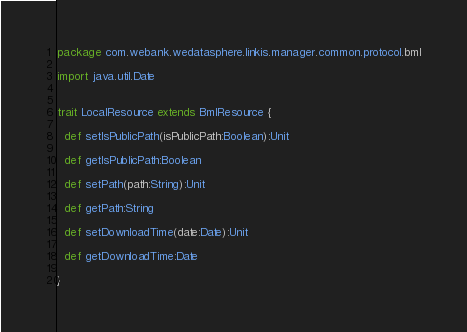Convert code to text. <code><loc_0><loc_0><loc_500><loc_500><_Scala_>package com.webank.wedatasphere.linkis.manager.common.protocol.bml

import java.util.Date


trait LocalResource extends BmlResource {

  def setIsPublicPath(isPublicPath:Boolean):Unit

  def getIsPublicPath:Boolean

  def setPath(path:String):Unit

  def getPath:String

  def setDownloadTime(date:Date):Unit

  def getDownloadTime:Date

}
</code> 